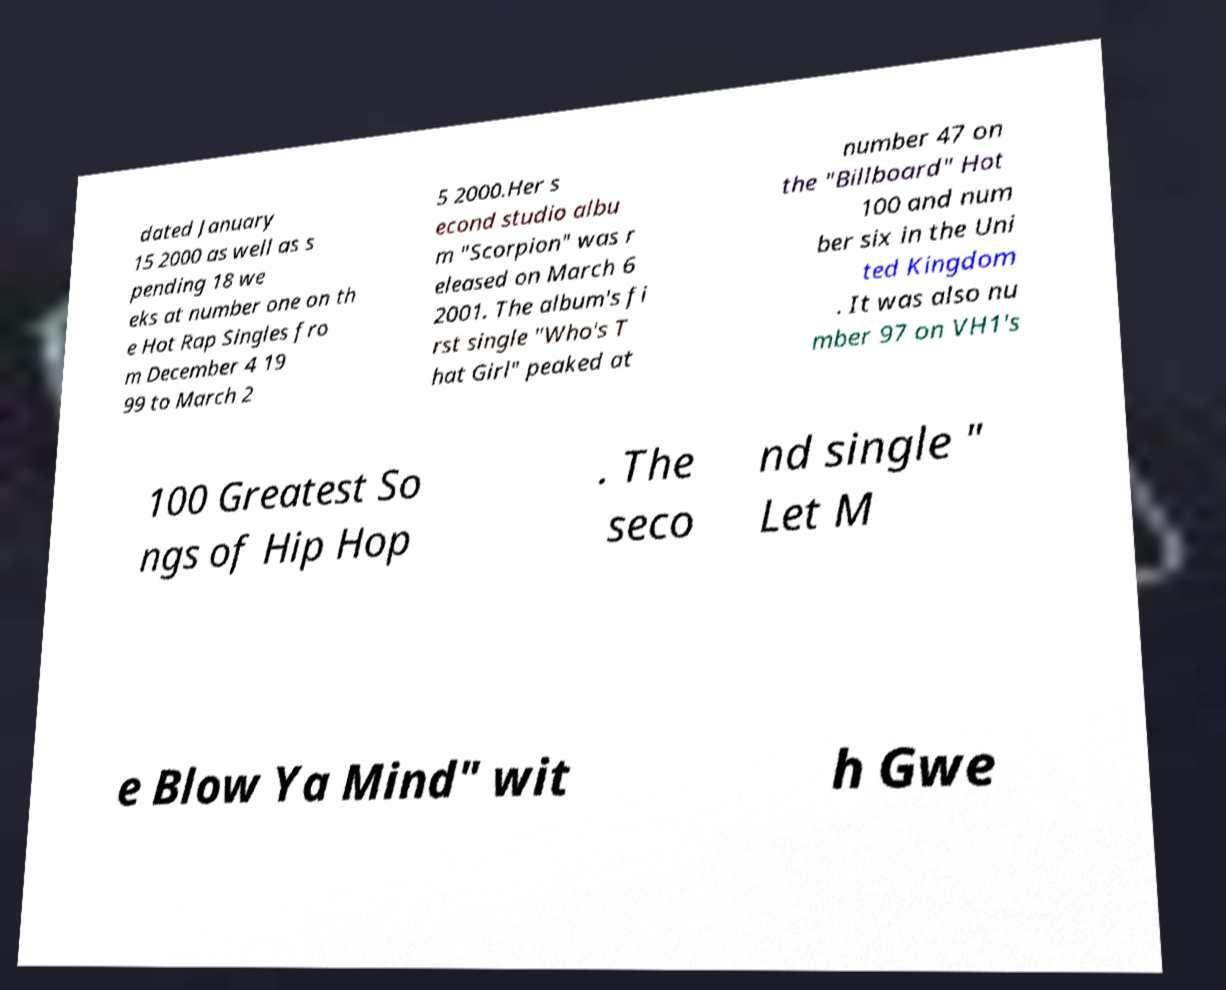What messages or text are displayed in this image? I need them in a readable, typed format. dated January 15 2000 as well as s pending 18 we eks at number one on th e Hot Rap Singles fro m December 4 19 99 to March 2 5 2000.Her s econd studio albu m "Scorpion" was r eleased on March 6 2001. The album's fi rst single "Who's T hat Girl" peaked at number 47 on the "Billboard" Hot 100 and num ber six in the Uni ted Kingdom . It was also nu mber 97 on VH1's 100 Greatest So ngs of Hip Hop . The seco nd single " Let M e Blow Ya Mind" wit h Gwe 